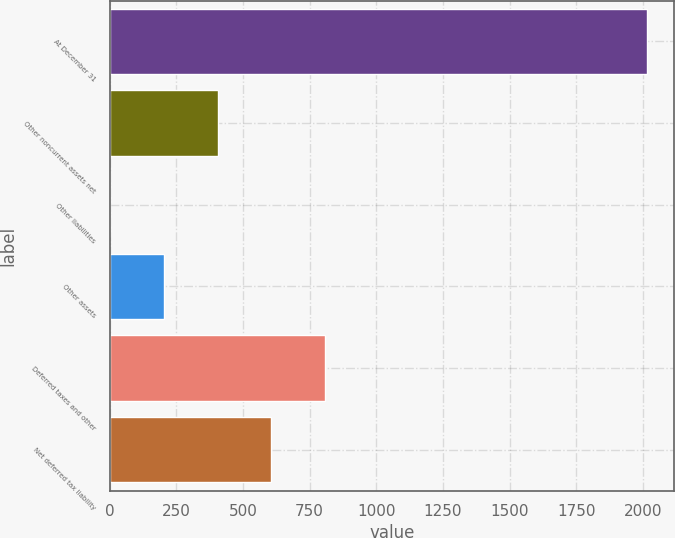Convert chart. <chart><loc_0><loc_0><loc_500><loc_500><bar_chart><fcel>At December 31<fcel>Other noncurrent assets net<fcel>Other liabilities<fcel>Other assets<fcel>Deferred taxes and other<fcel>Net deferred tax liability<nl><fcel>2017<fcel>404.92<fcel>1.9<fcel>203.41<fcel>807.94<fcel>606.43<nl></chart> 